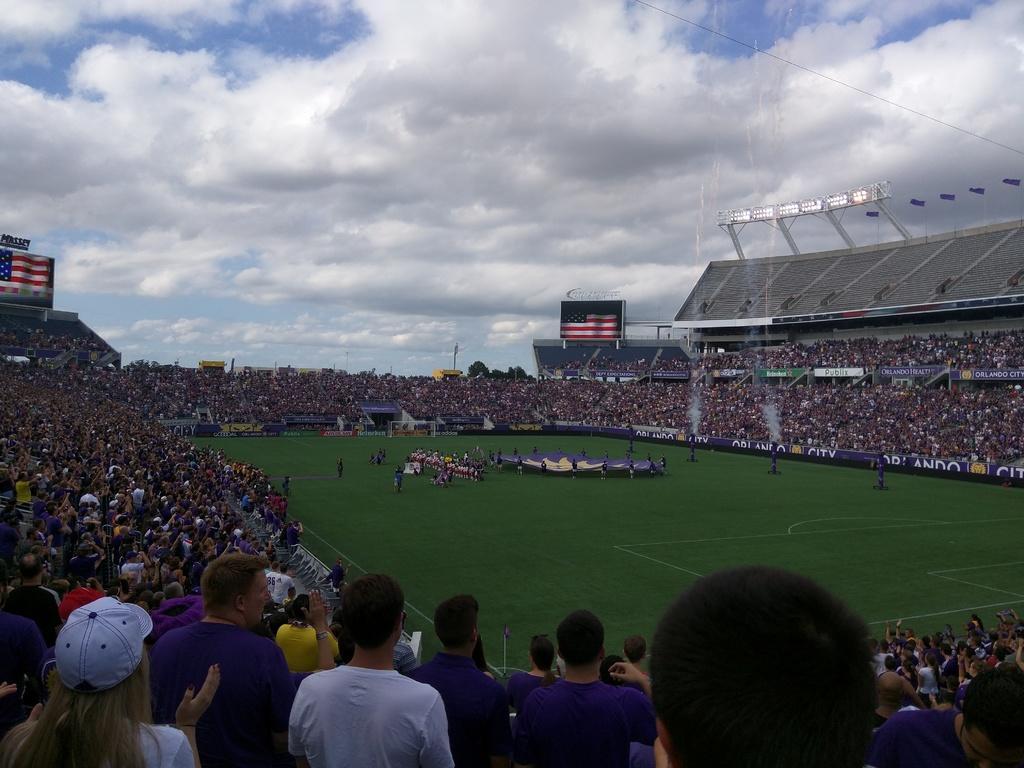Could you give a brief overview of what you see in this image? This image consists of a stadium. In the middle of the image I can see the ground. Here few people are standing. On the left side I can see many people are sitting on the chairs and looking at the ground. In the background also I can see many people. On the top of the image I can see the sky and clouds. 